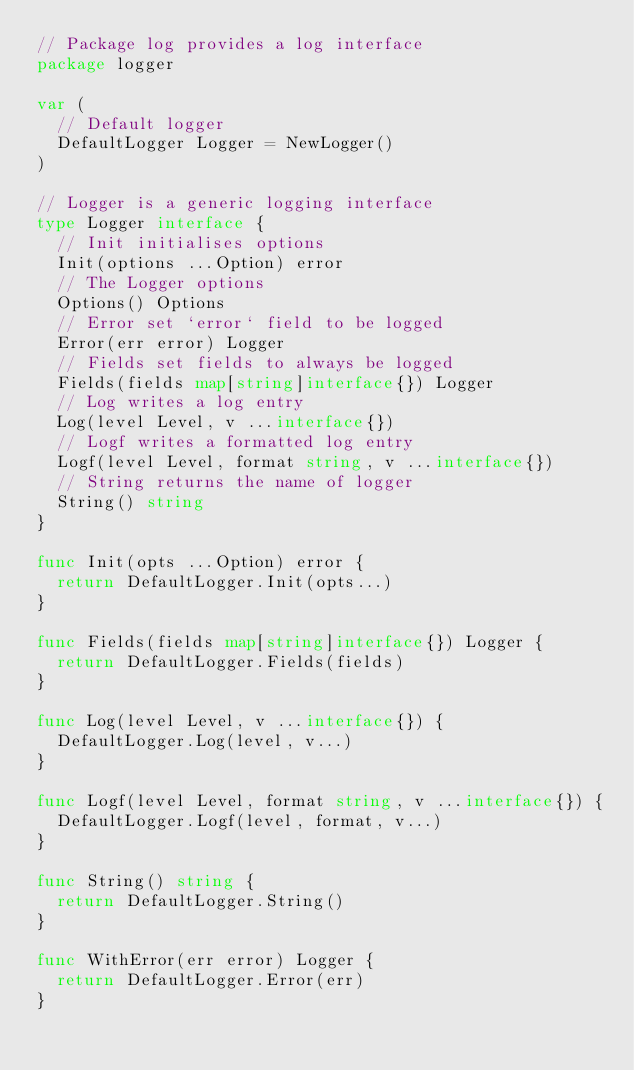<code> <loc_0><loc_0><loc_500><loc_500><_Go_>// Package log provides a log interface
package logger

var (
	// Default logger
	DefaultLogger Logger = NewLogger()
)

// Logger is a generic logging interface
type Logger interface {
	// Init initialises options
	Init(options ...Option) error
	// The Logger options
	Options() Options
	// Error set `error` field to be logged
	Error(err error) Logger
	// Fields set fields to always be logged
	Fields(fields map[string]interface{}) Logger
	// Log writes a log entry
	Log(level Level, v ...interface{})
	// Logf writes a formatted log entry
	Logf(level Level, format string, v ...interface{})
	// String returns the name of logger
	String() string
}

func Init(opts ...Option) error {
	return DefaultLogger.Init(opts...)
}

func Fields(fields map[string]interface{}) Logger {
	return DefaultLogger.Fields(fields)
}

func Log(level Level, v ...interface{}) {
	DefaultLogger.Log(level, v...)
}

func Logf(level Level, format string, v ...interface{}) {
	DefaultLogger.Logf(level, format, v...)
}

func String() string {
	return DefaultLogger.String()
}

func WithError(err error) Logger {
	return DefaultLogger.Error(err)
}
</code> 